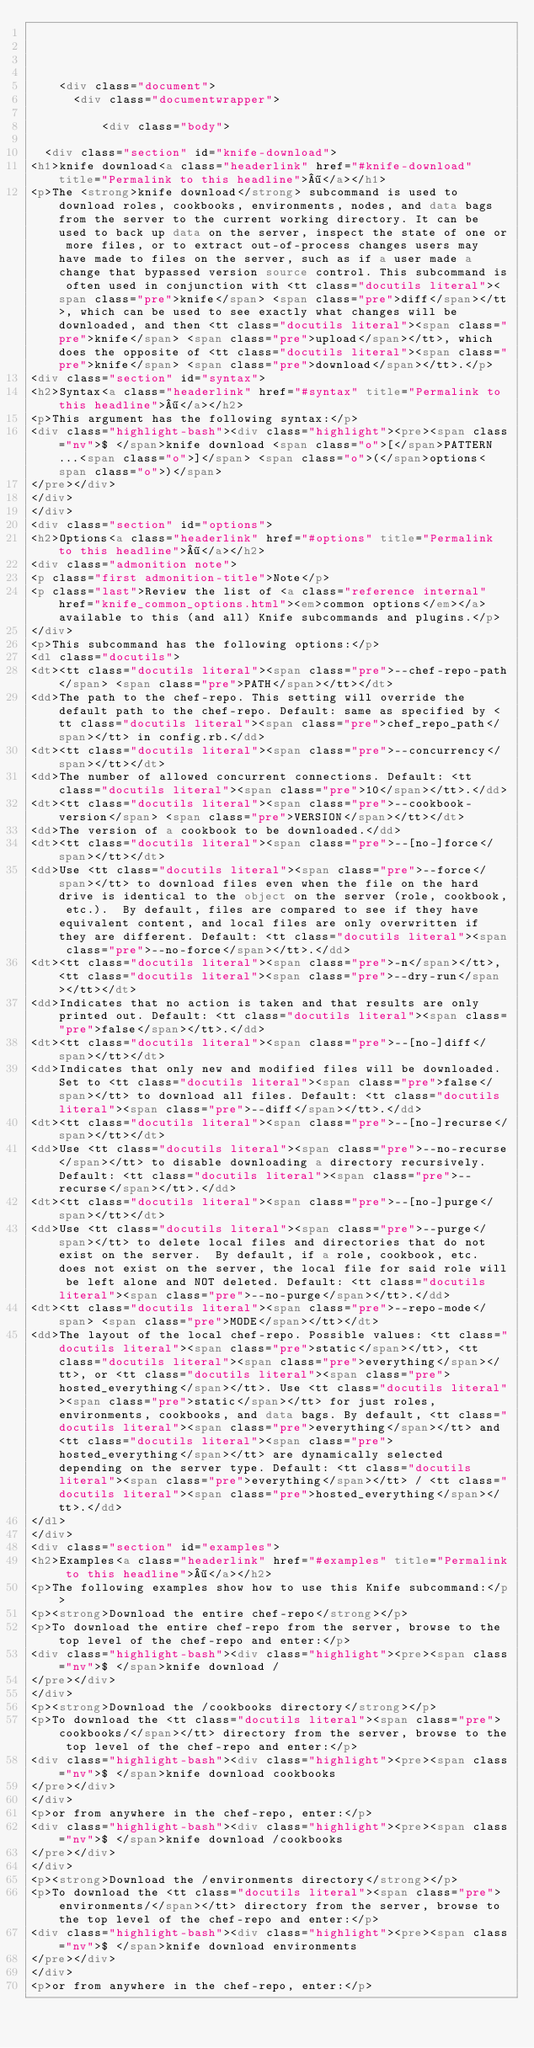<code> <loc_0><loc_0><loc_500><loc_500><_HTML_>

  

    <div class="document">
      <div class="documentwrapper">

          <div class="body">
            
  <div class="section" id="knife-download">
<h1>knife download<a class="headerlink" href="#knife-download" title="Permalink to this headline">¶</a></h1>
<p>The <strong>knife download</strong> subcommand is used to download roles, cookbooks, environments, nodes, and data bags from the server to the current working directory. It can be used to back up data on the server, inspect the state of one or more files, or to extract out-of-process changes users may have made to files on the server, such as if a user made a change that bypassed version source control. This subcommand is often used in conjunction with <tt class="docutils literal"><span class="pre">knife</span> <span class="pre">diff</span></tt>, which can be used to see exactly what changes will be downloaded, and then <tt class="docutils literal"><span class="pre">knife</span> <span class="pre">upload</span></tt>, which does the opposite of <tt class="docutils literal"><span class="pre">knife</span> <span class="pre">download</span></tt>.</p>
<div class="section" id="syntax">
<h2>Syntax<a class="headerlink" href="#syntax" title="Permalink to this headline">¶</a></h2>
<p>This argument has the following syntax:</p>
<div class="highlight-bash"><div class="highlight"><pre><span class="nv">$ </span>knife download <span class="o">[</span>PATTERN...<span class="o">]</span> <span class="o">(</span>options<span class="o">)</span>
</pre></div>
</div>
</div>
<div class="section" id="options">
<h2>Options<a class="headerlink" href="#options" title="Permalink to this headline">¶</a></h2>
<div class="admonition note">
<p class="first admonition-title">Note</p>
<p class="last">Review the list of <a class="reference internal" href="knife_common_options.html"><em>common options</em></a> available to this (and all) Knife subcommands and plugins.</p>
</div>
<p>This subcommand has the following options:</p>
<dl class="docutils">
<dt><tt class="docutils literal"><span class="pre">--chef-repo-path</span> <span class="pre">PATH</span></tt></dt>
<dd>The path to the chef-repo. This setting will override the default path to the chef-repo. Default: same as specified by <tt class="docutils literal"><span class="pre">chef_repo_path</span></tt> in config.rb.</dd>
<dt><tt class="docutils literal"><span class="pre">--concurrency</span></tt></dt>
<dd>The number of allowed concurrent connections. Default: <tt class="docutils literal"><span class="pre">10</span></tt>.</dd>
<dt><tt class="docutils literal"><span class="pre">--cookbook-version</span> <span class="pre">VERSION</span></tt></dt>
<dd>The version of a cookbook to be downloaded.</dd>
<dt><tt class="docutils literal"><span class="pre">--[no-]force</span></tt></dt>
<dd>Use <tt class="docutils literal"><span class="pre">--force</span></tt> to download files even when the file on the hard drive is identical to the object on the server (role, cookbook, etc.).  By default, files are compared to see if they have equivalent content, and local files are only overwritten if they are different. Default: <tt class="docutils literal"><span class="pre">--no-force</span></tt>.</dd>
<dt><tt class="docutils literal"><span class="pre">-n</span></tt>, <tt class="docutils literal"><span class="pre">--dry-run</span></tt></dt>
<dd>Indicates that no action is taken and that results are only printed out. Default: <tt class="docutils literal"><span class="pre">false</span></tt>.</dd>
<dt><tt class="docutils literal"><span class="pre">--[no-]diff</span></tt></dt>
<dd>Indicates that only new and modified files will be downloaded. Set to <tt class="docutils literal"><span class="pre">false</span></tt> to download all files. Default: <tt class="docutils literal"><span class="pre">--diff</span></tt>.</dd>
<dt><tt class="docutils literal"><span class="pre">--[no-]recurse</span></tt></dt>
<dd>Use <tt class="docutils literal"><span class="pre">--no-recurse</span></tt> to disable downloading a directory recursively. Default: <tt class="docutils literal"><span class="pre">--recurse</span></tt>.</dd>
<dt><tt class="docutils literal"><span class="pre">--[no-]purge</span></tt></dt>
<dd>Use <tt class="docutils literal"><span class="pre">--purge</span></tt> to delete local files and directories that do not exist on the server.  By default, if a role, cookbook, etc. does not exist on the server, the local file for said role will be left alone and NOT deleted. Default: <tt class="docutils literal"><span class="pre">--no-purge</span></tt>.</dd>
<dt><tt class="docutils literal"><span class="pre">--repo-mode</span> <span class="pre">MODE</span></tt></dt>
<dd>The layout of the local chef-repo. Possible values: <tt class="docutils literal"><span class="pre">static</span></tt>, <tt class="docutils literal"><span class="pre">everything</span></tt>, or <tt class="docutils literal"><span class="pre">hosted_everything</span></tt>. Use <tt class="docutils literal"><span class="pre">static</span></tt> for just roles, environments, cookbooks, and data bags. By default, <tt class="docutils literal"><span class="pre">everything</span></tt> and <tt class="docutils literal"><span class="pre">hosted_everything</span></tt> are dynamically selected depending on the server type. Default: <tt class="docutils literal"><span class="pre">everything</span></tt> / <tt class="docutils literal"><span class="pre">hosted_everything</span></tt>.</dd>
</dl>
</div>
<div class="section" id="examples">
<h2>Examples<a class="headerlink" href="#examples" title="Permalink to this headline">¶</a></h2>
<p>The following examples show how to use this Knife subcommand:</p>
<p><strong>Download the entire chef-repo</strong></p>
<p>To download the entire chef-repo from the server, browse to the top level of the chef-repo and enter:</p>
<div class="highlight-bash"><div class="highlight"><pre><span class="nv">$ </span>knife download /
</pre></div>
</div>
<p><strong>Download the /cookbooks directory</strong></p>
<p>To download the <tt class="docutils literal"><span class="pre">cookbooks/</span></tt> directory from the server, browse to the top level of the chef-repo and enter:</p>
<div class="highlight-bash"><div class="highlight"><pre><span class="nv">$ </span>knife download cookbooks
</pre></div>
</div>
<p>or from anywhere in the chef-repo, enter:</p>
<div class="highlight-bash"><div class="highlight"><pre><span class="nv">$ </span>knife download /cookbooks
</pre></div>
</div>
<p><strong>Download the /environments directory</strong></p>
<p>To download the <tt class="docutils literal"><span class="pre">environments/</span></tt> directory from the server, browse to the top level of the chef-repo and enter:</p>
<div class="highlight-bash"><div class="highlight"><pre><span class="nv">$ </span>knife download environments
</pre></div>
</div>
<p>or from anywhere in the chef-repo, enter:</p></code> 